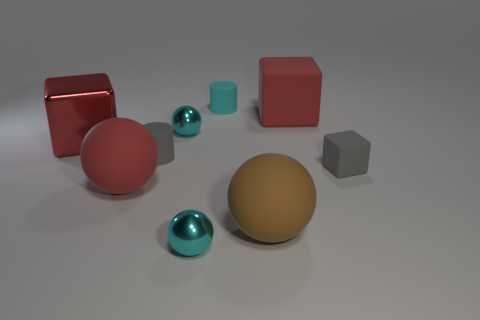There is another block that is the same color as the large matte block; what material is it?
Make the answer very short. Metal. Do the ball that is on the left side of the gray rubber cylinder and the small cyan sphere that is in front of the big brown thing have the same material?
Keep it short and to the point. No. Are there more small rubber objects than big objects?
Offer a very short reply. No. There is a metal sphere that is in front of the tiny gray cylinder that is in front of the big block on the left side of the brown object; what is its color?
Provide a short and direct response. Cyan. There is a tiny metallic sphere behind the small gray matte cube; is its color the same as the matte block that is to the left of the tiny block?
Your answer should be very brief. No. There is a big red sphere that is on the left side of the big red rubber block; what number of tiny cyan balls are behind it?
Provide a succinct answer. 1. Are any large yellow matte objects visible?
Make the answer very short. No. How many other things are there of the same color as the big shiny object?
Your answer should be very brief. 2. Are there fewer large red blocks than big purple rubber blocks?
Keep it short and to the point. No. What is the shape of the large red rubber thing left of the large brown rubber thing that is in front of the large metal object?
Your response must be concise. Sphere. 